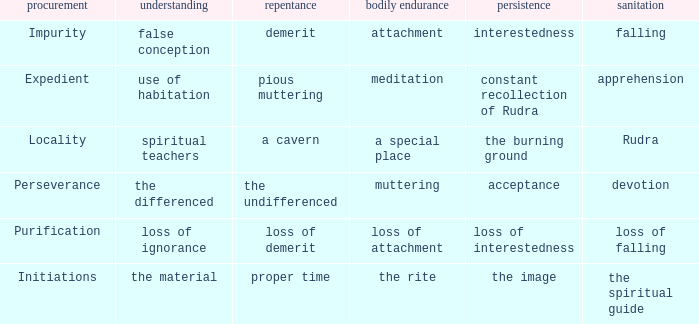 what's the permanence of the body where purity is apprehension Meditation. 